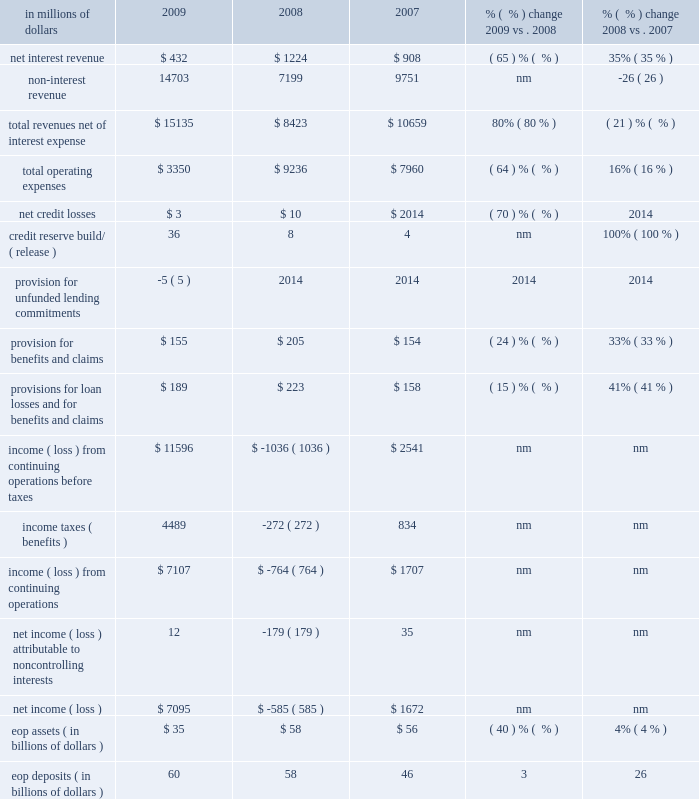Brokerage and asset management brokerage and asset management ( bam ) , which constituted approximately 6% ( 6 % ) of citi holdings by assets as of december 31 , 2009 , consists of citi 2019s global retail brokerage and asset management businesses .
This segment was substantially affected and reduced in size in 2009 due to the divestitures of smith barney ( to the morgan stanley smith barney joint venture ( mssb jv ) ) and nikko cordial securities .
At december 31 , 2009 , bam had approximately $ 35 billion of assets , which included $ 26 billion of assets from the 49% ( 49 % ) interest in the mssb jv ( $ 13 billion investment and $ 13 billion in loans associated with the clients of the mssb jv ) and $ 9 billion of assets from a diverse set of asset management and insurance businesses of which approximately half will be transferred into the latam rcb during the first quarter of 2010 , as discussed under 201cciti holdings 201d above .
Morgan stanley has options to purchase citi 2019s remaining stake in the mssb jv over three years starting in 2012 .
The 2009 results include an $ 11.1 billion gain ( $ 6.7 billion after-tax ) on the sale of smith barney .
In millions of dollars 2009 2008 2007 % (  % ) change 2009 vs .
2008 % (  % ) change 2008 vs .
2007 .
Nm not meaningful 2009 vs .
2008 revenues , net of interest expense increased 80% ( 80 % ) versus the prior year mainly driven by the $ 11.1 billion pretax gain on the sale ( $ 6.7 billion after-tax ) on the mssb jv transaction in the second quarter of 2009 and a $ 320 million pretax gain on the sale of the managed futures business to the mssb jv in the third quarter of 2009 .
Excluding these gains , revenue decreased primarily due to the absence of smith barney from may 2009 onwards and the absence of fourth-quarter revenue of nikko asset management , partially offset by an improvement in marks in retail alternative investments .
Revenues in the prior year include a $ 347 million pretax gain on sale of citistreet and charges related to the settlement of auction rate securities of $ 393 million pretax .
Operating expenses decreased 64% ( 64 % ) from the prior year , mainly driven by the absence of smith barney and nikko asset management expenses , re- engineering efforts and the absence of 2008 one-time expenses ( $ 0.9 billion intangible impairment , $ 0.2 billion of restructuring and $ 0.5 billion of write- downs and other charges ) .
Provisions for loan losses and for benefits and claims decreased 15% ( 15 % ) mainly reflecting a $ 50 million decrease in provision for benefits and claims , partially offset by increased reserve builds of $ 28 million .
Assets decreased 40% ( 40 % ) versus the prior year , mostly driven by the sales of nikko cordial securities and nikko asset management ( $ 25 billion ) and the managed futures business ( $ 1.4 billion ) , partially offset by increased smith barney assets of $ 4 billion .
2008 vs .
2007 revenues , net of interest expense decreased 21% ( 21 % ) from the prior year primarily due to lower transactional and investment revenues in smith barney , lower revenues in nikko asset management and higher markdowns in retail alternative investments .
Operating expenses increased 16% ( 16 % ) versus the prior year , mainly driven by a $ 0.9 billion intangible impairment in nikko asset management in the fourth quarter of 2008 , $ 0.2 billion of restructuring charges and $ 0.5 billion of write-downs and other charges .
Provisions for loan losses and for benefits and claims increased $ 65 million compared to the prior year , mainly due to a $ 52 million increase in provisions for benefits and claims .
Assets increased 4% ( 4 % ) versus the prior year. .
As a percent of total revenues net of interest expense what was non-interest revenue in 2009? 
Computations: (14703 / 15135)
Answer: 0.97146. 